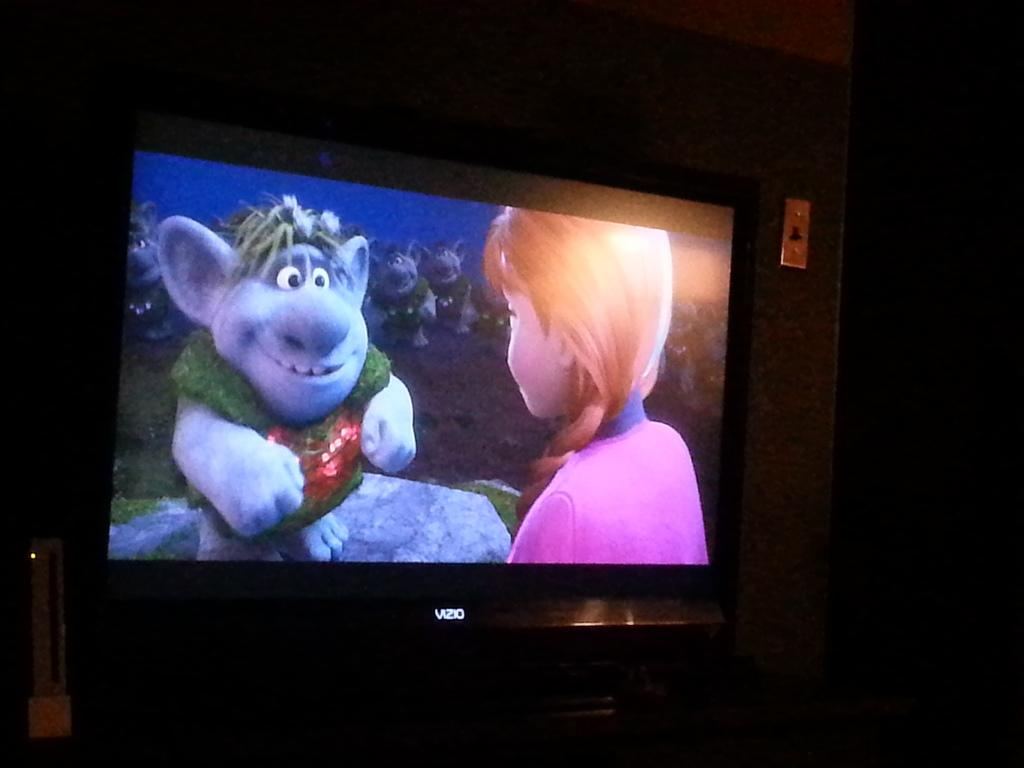<image>
Describe the image concisely. The children's movie is being watched on a Vizio brand television. 